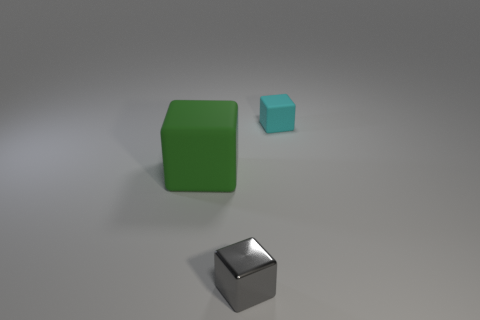Add 1 big yellow things. How many objects exist? 4 Add 2 tiny blocks. How many tiny blocks are left? 4 Add 1 small gray cubes. How many small gray cubes exist? 2 Subtract 0 brown blocks. How many objects are left? 3 Subtract all gray metal blocks. Subtract all big green things. How many objects are left? 1 